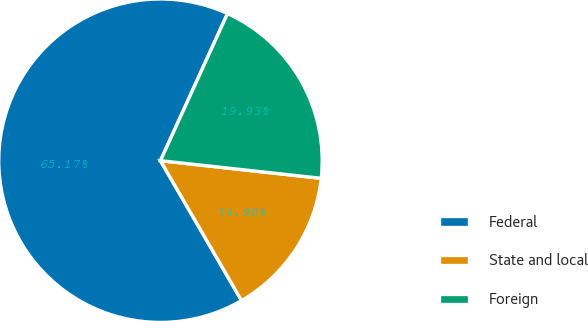Convert chart. <chart><loc_0><loc_0><loc_500><loc_500><pie_chart><fcel>Federal<fcel>State and local<fcel>Foreign<nl><fcel>65.16%<fcel>14.9%<fcel>19.93%<nl></chart> 